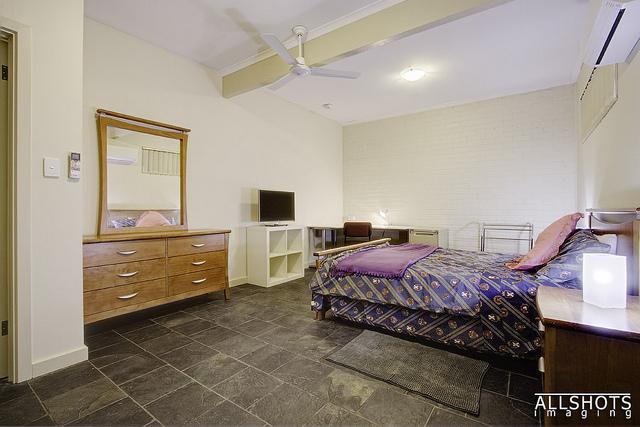Has anyone slept in the bed recently?
Short answer required. No. Is there a dresser in the room?
Write a very short answer. Yes. Is this a hotel?
Be succinct. No. 